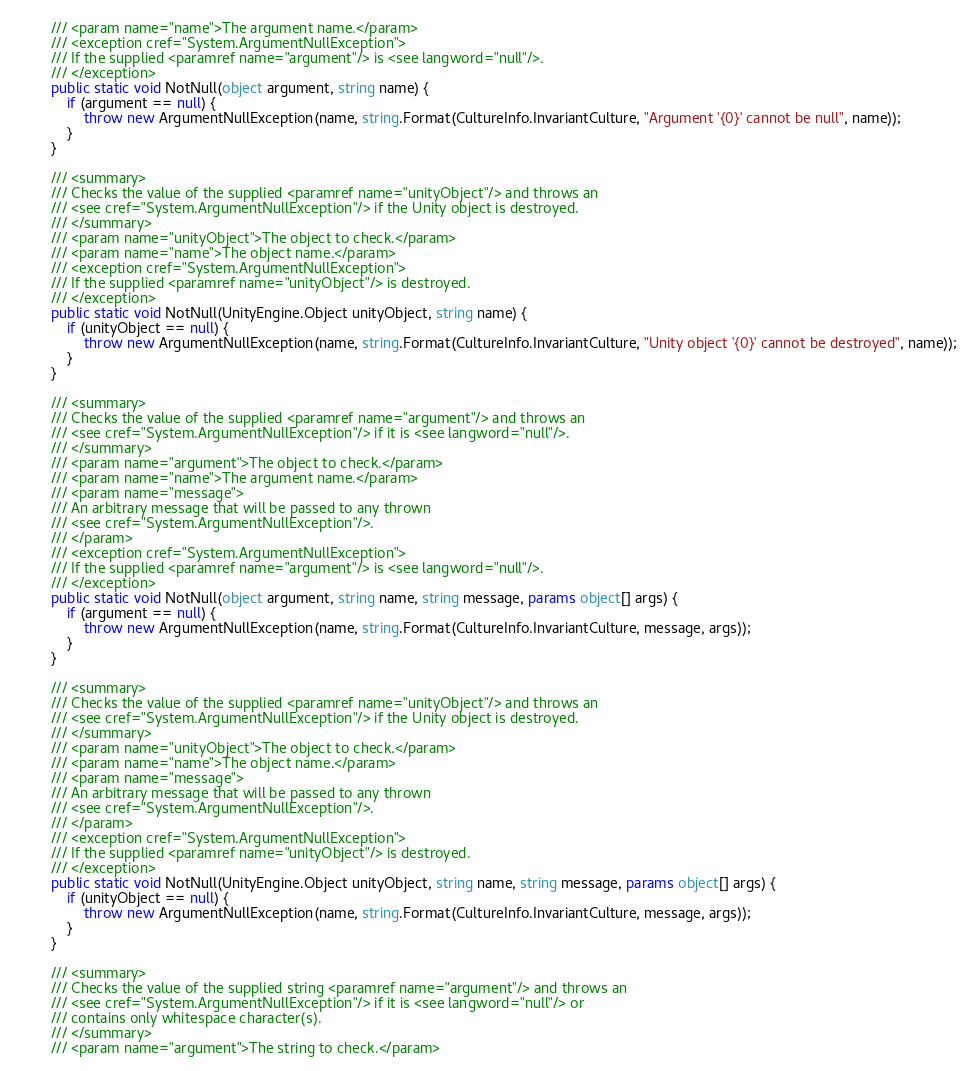Convert code to text. <code><loc_0><loc_0><loc_500><loc_500><_C#_>        /// <param name="name">The argument name.</param>
        /// <exception cref="System.ArgumentNullException">
        /// If the supplied <paramref name="argument"/> is <see langword="null"/>.
        /// </exception>
        public static void NotNull(object argument, string name) {
            if (argument == null) {
                throw new ArgumentNullException(name, string.Format(CultureInfo.InvariantCulture, "Argument '{0}' cannot be null", name));
            }
        }

        /// <summary>
        /// Checks the value of the supplied <paramref name="unityObject"/> and throws an
        /// <see cref="System.ArgumentNullException"/> if the Unity object is destroyed.
        /// </summary>
        /// <param name="unityObject">The object to check.</param>
        /// <param name="name">The object name.</param>
        /// <exception cref="System.ArgumentNullException">
        /// If the supplied <paramref name="unityObject"/> is destroyed.
        /// </exception>
        public static void NotNull(UnityEngine.Object unityObject, string name) {
            if (unityObject == null) {
                throw new ArgumentNullException(name, string.Format(CultureInfo.InvariantCulture, "Unity object '{0}' cannot be destroyed", name));
            }
        }

        /// <summary>
        /// Checks the value of the supplied <paramref name="argument"/> and throws an
        /// <see cref="System.ArgumentNullException"/> if it is <see langword="null"/>.
        /// </summary>
        /// <param name="argument">The object to check.</param>
        /// <param name="name">The argument name.</param>
        /// <param name="message">
        /// An arbitrary message that will be passed to any thrown
        /// <see cref="System.ArgumentNullException"/>.
        /// </param>
        /// <exception cref="System.ArgumentNullException">
        /// If the supplied <paramref name="argument"/> is <see langword="null"/>.
        /// </exception>
        public static void NotNull(object argument, string name, string message, params object[] args) {
            if (argument == null) {
                throw new ArgumentNullException(name, string.Format(CultureInfo.InvariantCulture, message, args));
            }
        }

        /// <summary>
        /// Checks the value of the supplied <paramref name="unityObject"/> and throws an
        /// <see cref="System.ArgumentNullException"/> if the Unity object is destroyed.
        /// </summary>
        /// <param name="unityObject">The object to check.</param>
        /// <param name="name">The object name.</param>
        /// <param name="message">
        /// An arbitrary message that will be passed to any thrown
        /// <see cref="System.ArgumentNullException"/>.
        /// </param>
        /// <exception cref="System.ArgumentNullException">
        /// If the supplied <paramref name="unityObject"/> is destroyed.
        /// </exception>
        public static void NotNull(UnityEngine.Object unityObject, string name, string message, params object[] args) {
            if (unityObject == null) {
                throw new ArgumentNullException(name, string.Format(CultureInfo.InvariantCulture, message, args));
            }
        }

        /// <summary>
        /// Checks the value of the supplied string <paramref name="argument"/> and throws an
        /// <see cref="System.ArgumentNullException"/> if it is <see langword="null"/> or
        /// contains only whitespace character(s).
        /// </summary>
        /// <param name="argument">The string to check.</param></code> 